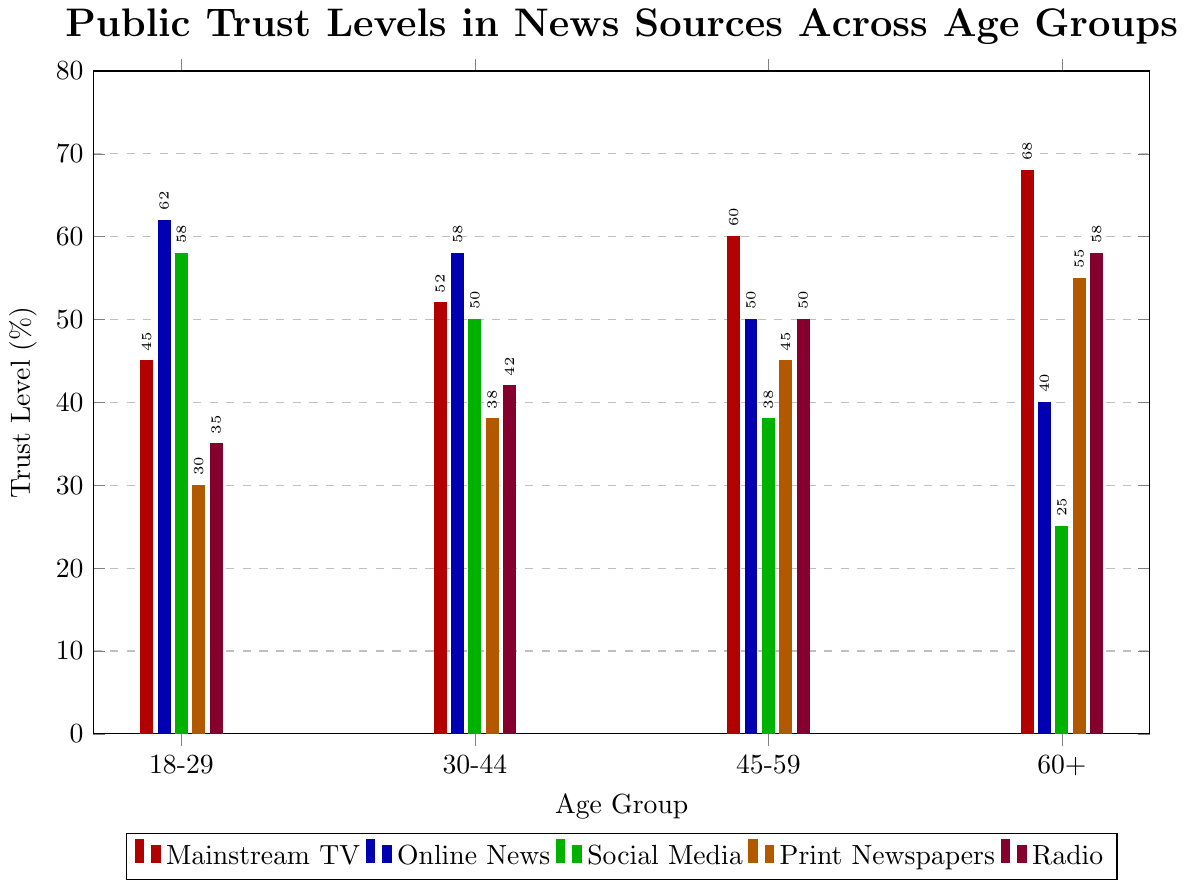What age group has the highest trust level in mainstream TV? The bar with the highest height for mainstream TV is in the 60+ age group. This bar represents a trust level of 68%.
Answer: 60+ Which news source has the lowest trust level among the 18-29 age group? The bar representing print newspapers for the 18-29 age group is the shortest, indicating a trust level of 30%.
Answer: Print Newspapers Compare the trust levels in online news and social media for the 30-44 age group. Which one is higher? For the 30-44 age group, the trust level bar for online news is higher than the one for social media. Online news has a trust level of 58%, while social media has 50%.
Answer: Online News What is the difference in trust levels between radio and print newspapers for the 60+ age group? The trust level for radio in the 60+ group is 58%, and for print newspapers, it is 55%. The difference is 58% - 55% = 3%.
Answer: 3% Which age group has the lowest trust level in social media? The shortest bar for social media is in the 60+ age group, with a trust level of 25%.
Answer: 60+ What are the trust levels of radio for all age groups? The heights of the radio bars for age groups 18-29, 30-44, 45-59, and 60+ are 35%, 42%, 50%, and 58%, respectively.
Answer: 35%, 42%, 50%, 58% How does the trust level in print newspapers change from the 18-29 age group to the 60+ age group? The trust levels in print newspapers for the age groups are: 18-29 (30%), 30-44 (38%), 45-59 (45%), 60+ (55%). It increases continuously across these age groups.
Answer: It increases from 30% to 55% Calculate the average trust level in social media across all age groups. The trust levels in social media for age groups 18-29, 30-44, 45-59, and 60+ are 58%, 50%, 38%, and 25%, respectively. Sum these values (58 + 50 + 38 + 25 = 171) and divide by 4 to find the average: 171 / 4 = 42.75%.
Answer: 42.75% What is the combined trust level in mainstream TV and radio for the 45-59 age group? The trust levels in mainstream TV and radio for the 45-59 age group are 60% and 50%, respectively. The sum is 60% + 50% = 110%.
Answer: 110% 